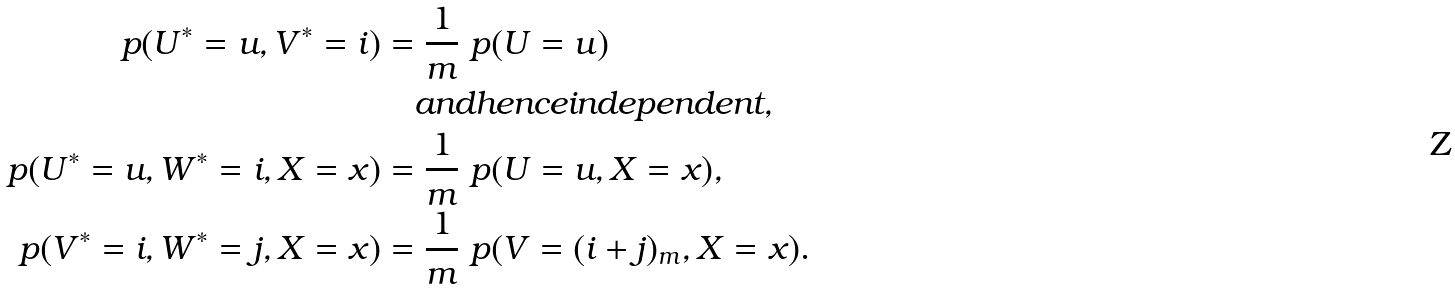<formula> <loc_0><loc_0><loc_500><loc_500>\ p ( U ^ { * } = u , V ^ { * } = i ) & = \frac { 1 } { m } \ p ( U = u ) \\ & \quad a n d h e n c e i n d e p e n d e n t , \\ \ p ( U ^ { * } = u , W ^ { * } = i , X = x ) & = \frac { 1 } { m } \ p ( U = u , X = x ) , \\ \ p ( V ^ { * } = i , W ^ { * } = j , X = x ) & = \frac { 1 } { m } \ p ( V = ( i + j ) _ { m } , X = x ) .</formula> 